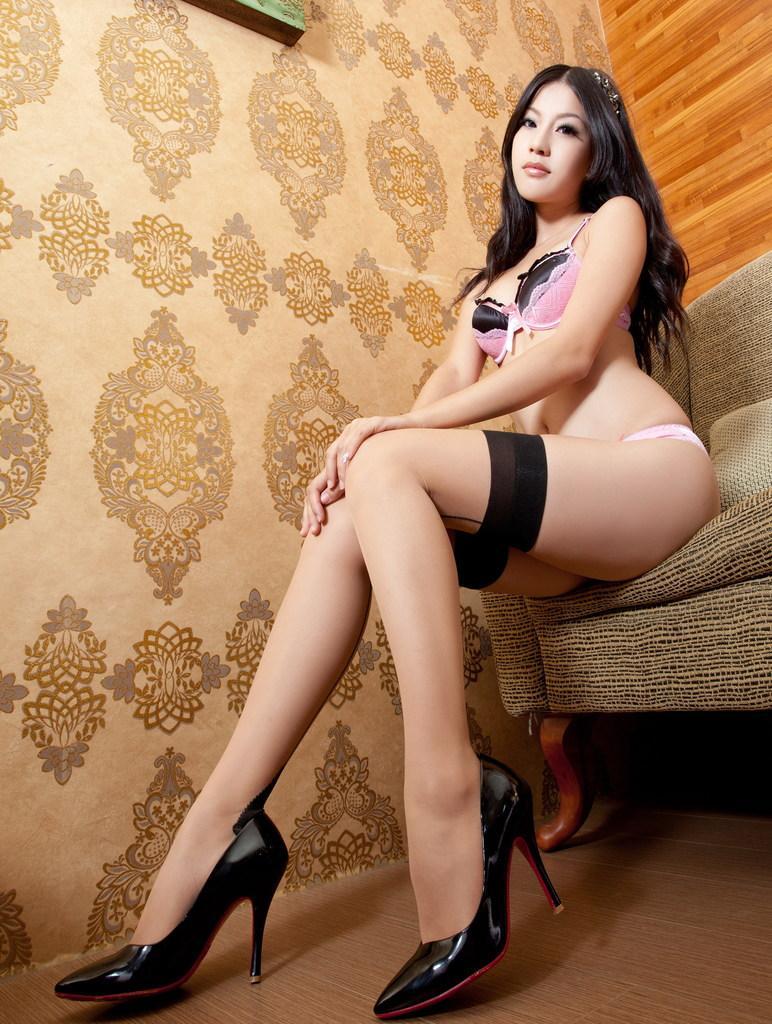Describe this image in one or two sentences. In this image we can see a lady sitting on the couch. There is an object on the wall at the top of the image. There is some design on the wall. 